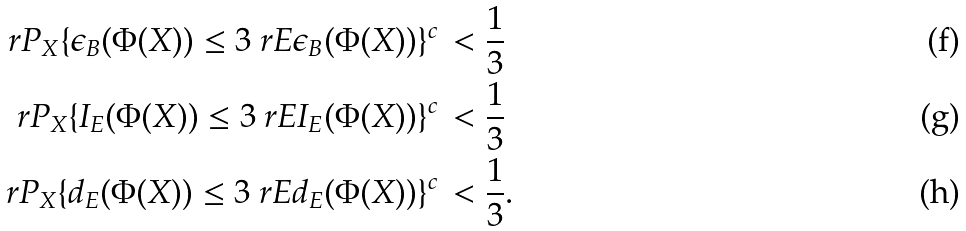<formula> <loc_0><loc_0><loc_500><loc_500>\ r P _ { X } \{ \epsilon _ { B } ( \Phi ( X ) ) \leq 3 \ r E \epsilon _ { B } ( \Phi ( X ) ) \} ^ { c } & \, < \frac { 1 } { 3 } \\ \ r P _ { X } \{ I _ { E } ( \Phi ( X ) ) \leq 3 \ r E I _ { E } ( \Phi ( X ) ) \} ^ { c } & \, < \frac { 1 } { 3 } \\ \ r P _ { X } \{ d _ { E } ( \Phi ( X ) ) \leq 3 \ r E d _ { E } ( \Phi ( X ) ) \} ^ { c } & \, < \frac { 1 } { 3 } .</formula> 